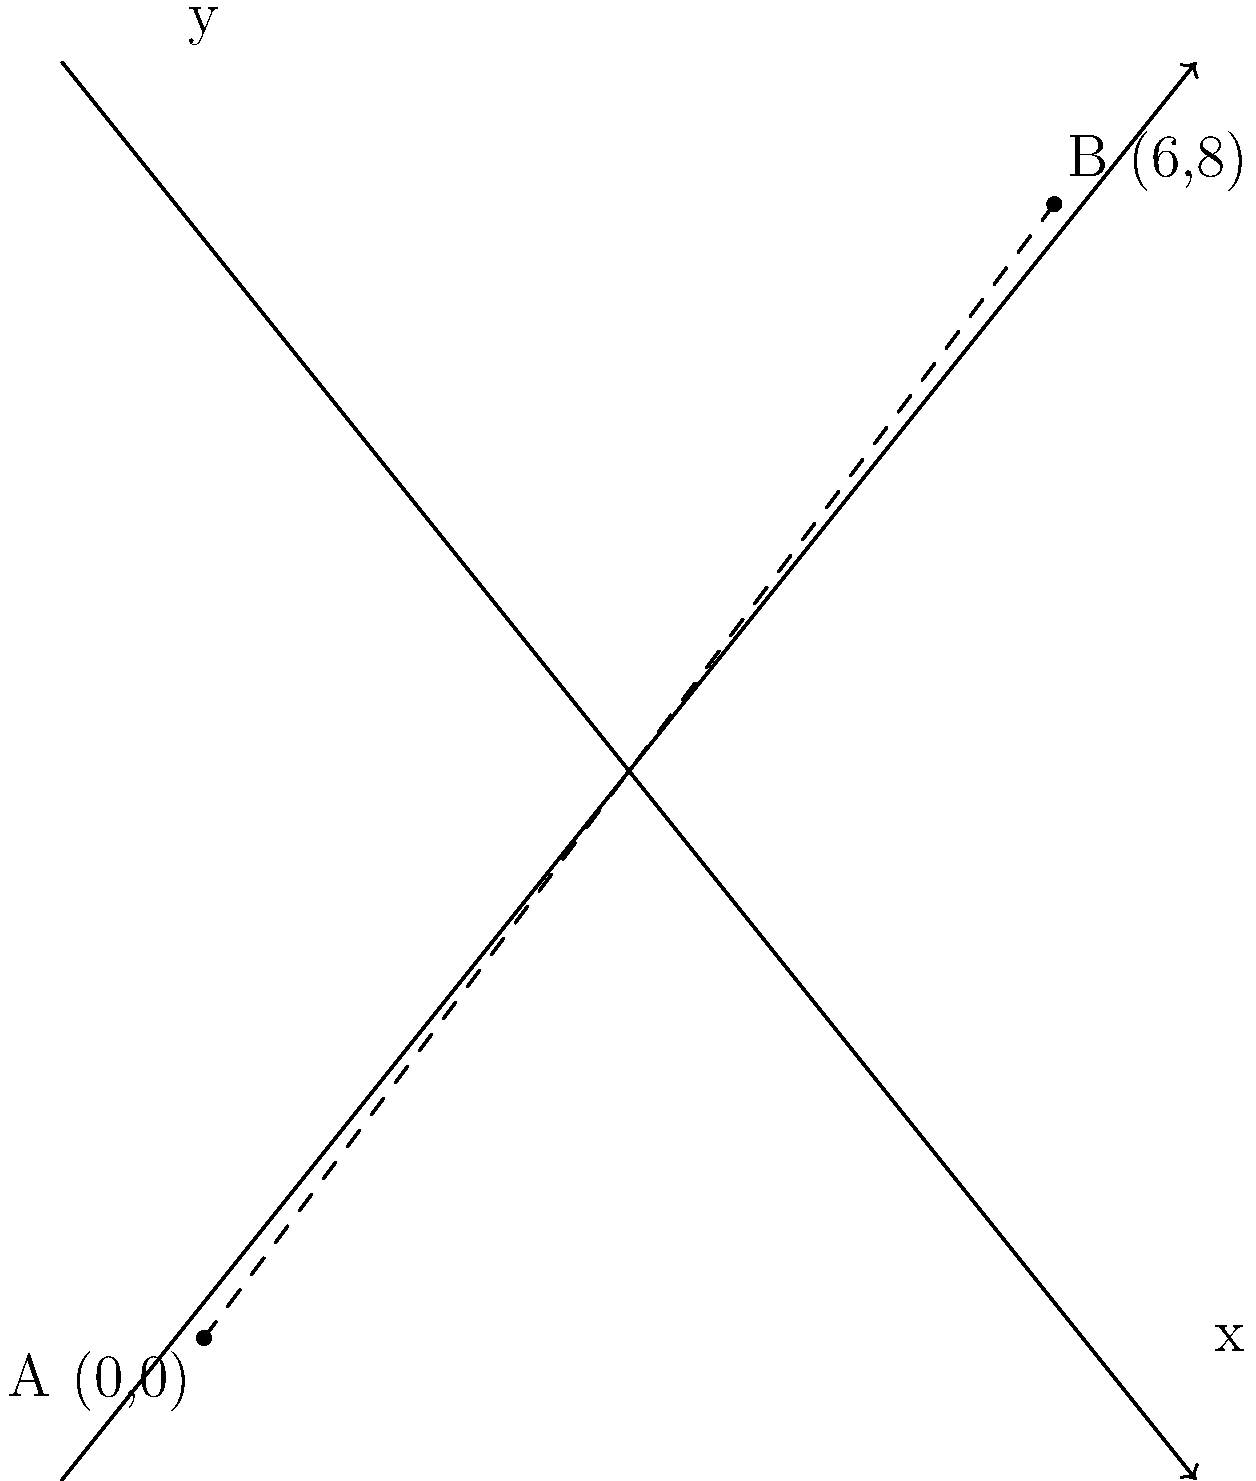As a historical researcher, you're studying the geographical relationship between two ancient religious sites. Site A is located at coordinates (0,0) and Site B is at coordinates (6,8) on a map grid where each unit represents 1 kilometer. Using the distance formula, calculate the straight-line distance between these two sites. To solve this problem, we'll use the distance formula derived from the Pythagorean theorem:

$d = \sqrt{(x_2 - x_1)^2 + (y_2 - y_1)^2}$

Where $(x_1, y_1)$ are the coordinates of Site A and $(x_2, y_2)$ are the coordinates of Site B.

Step 1: Identify the coordinates
Site A: $(x_1, y_1) = (0, 0)$
Site B: $(x_2, y_2) = (6, 8)$

Step 2: Plug the coordinates into the distance formula
$d = \sqrt{(6 - 0)^2 + (8 - 0)^2}$

Step 3: Simplify the expressions inside the parentheses
$d = \sqrt{6^2 + 8^2}$

Step 4: Calculate the squares
$d = \sqrt{36 + 64}$

Step 5: Add the values under the square root
$d = \sqrt{100}$

Step 6: Simplify the square root
$d = 10$

Therefore, the straight-line distance between the two ancient religious sites is 10 kilometers.
Answer: 10 km 